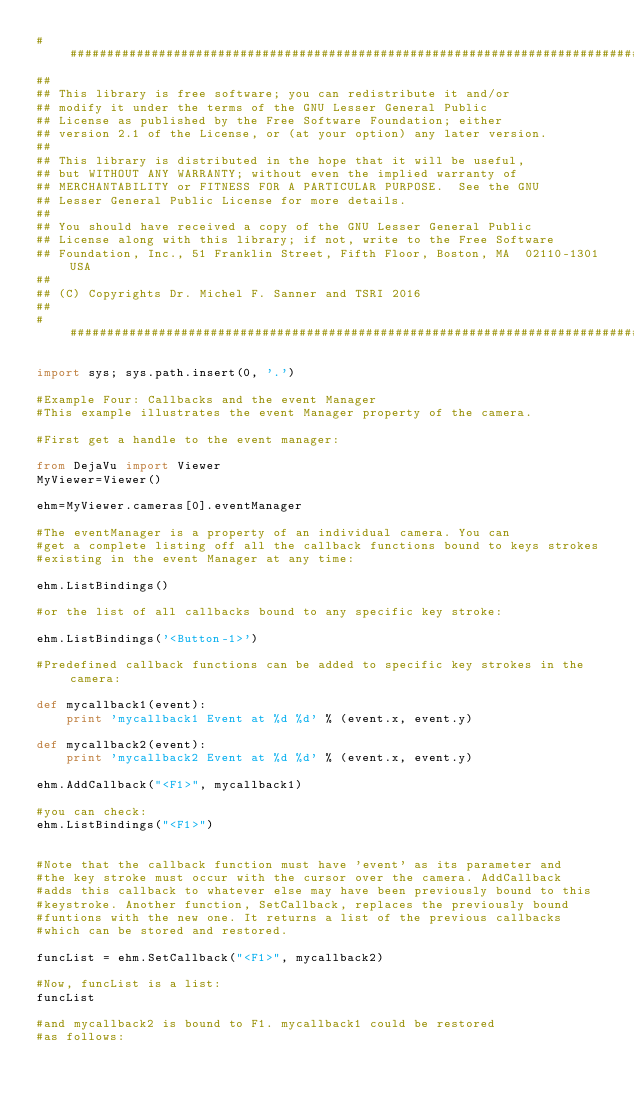<code> <loc_0><loc_0><loc_500><loc_500><_Python_>################################################################################
##
## This library is free software; you can redistribute it and/or
## modify it under the terms of the GNU Lesser General Public
## License as published by the Free Software Foundation; either
## version 2.1 of the License, or (at your option) any later version.
## 
## This library is distributed in the hope that it will be useful,
## but WITHOUT ANY WARRANTY; without even the implied warranty of
## MERCHANTABILITY or FITNESS FOR A PARTICULAR PURPOSE.  See the GNU
## Lesser General Public License for more details.
## 
## You should have received a copy of the GNU Lesser General Public
## License along with this library; if not, write to the Free Software
## Foundation, Inc., 51 Franklin Street, Fifth Floor, Boston, MA  02110-1301 USA
##
## (C) Copyrights Dr. Michel F. Sanner and TSRI 2016
##
################################################################################

import sys; sys.path.insert(0, '.')

#Example Four: Callbacks and the event Manager
#This example illustrates the event Manager property of the camera.

#First get a handle to the event manager:

from DejaVu import Viewer
MyViewer=Viewer()

ehm=MyViewer.cameras[0].eventManager

#The eventManager is a property of an individual camera. You can
#get a complete listing off all the callback functions bound to keys strokes
#existing in the event Manager at any time:

ehm.ListBindings()

#or the list of all callbacks bound to any specific key stroke:

ehm.ListBindings('<Button-1>')

#Predefined callback functions can be added to specific key strokes in the camera:

def mycallback1(event):
	print 'mycallback1 Event at %d %d' % (event.x, event.y)

def mycallback2(event):
	print 'mycallback2 Event at %d %d' % (event.x, event.y)

ehm.AddCallback("<F1>", mycallback1)

#you can check:
ehm.ListBindings("<F1>") 


#Note that the callback function must have 'event' as its parameter and
#the key stroke must occur with the cursor over the camera. AddCallback
#adds this callback to whatever else may have been previously bound to this
#keystroke. Another function, SetCallback, replaces the previously bound
#funtions with the new one. It returns a list of the previous callbacks
#which can be stored and restored.

funcList = ehm.SetCallback("<F1>", mycallback2)

#Now, funcList is a list:
funcList

#and mycallback2 is bound to F1. mycallback1 could be restored
#as follows:
</code> 